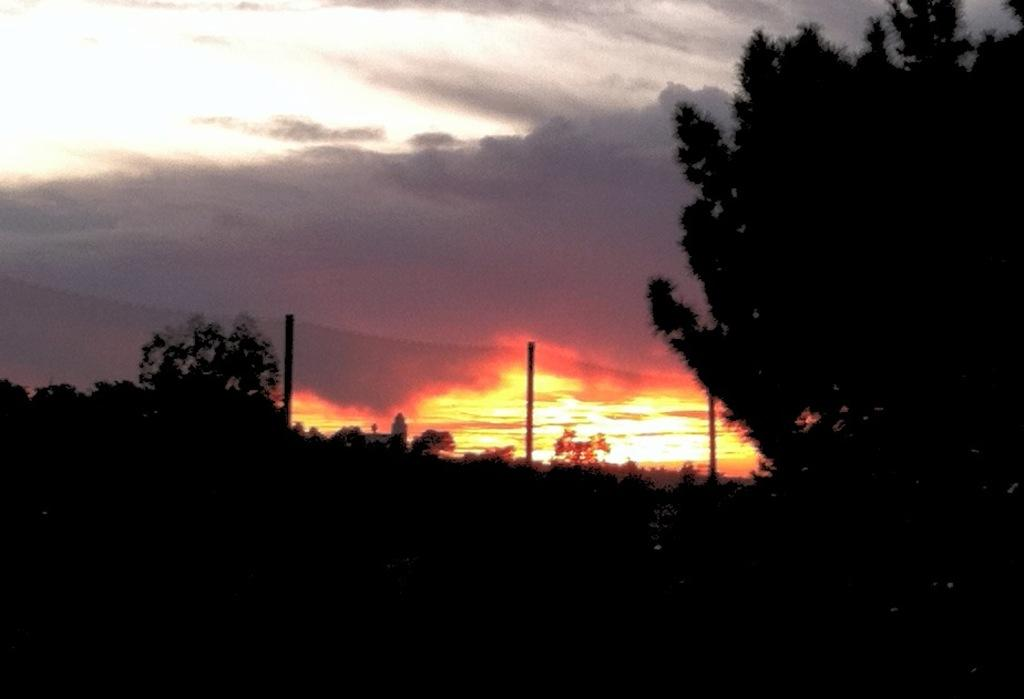What type of natural environment is depicted in the image? The image features many trees, suggesting a forest or wooded area. What geographical feature can be seen on the left side of the image? There is a hill on the left side of the image. What man-made objects are visible in the image? Poles are visible in the image. How would you describe the weather in the image? The sky is cloudy at the top of the image, indicating a potentially overcast or cloudy day. What is the opinion of the trees about the bridge in the image? There is no bridge present in the image, and trees do not have opinions. 